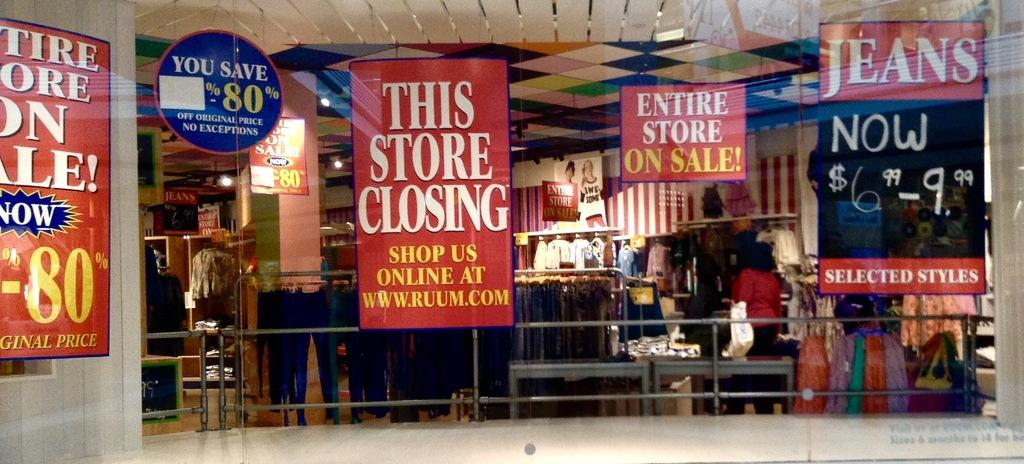Who or what can be seen in the image? There are people in the image. What else is present in the image besides people? There are hoardings, metal rods, clothes, and lights in the image. What type of scissors are being used by the people in the image? There are no scissors present in the image. Are the people in the image sleeping or resting? The image does not show the people sleeping or resting; they are engaged in other activities. 